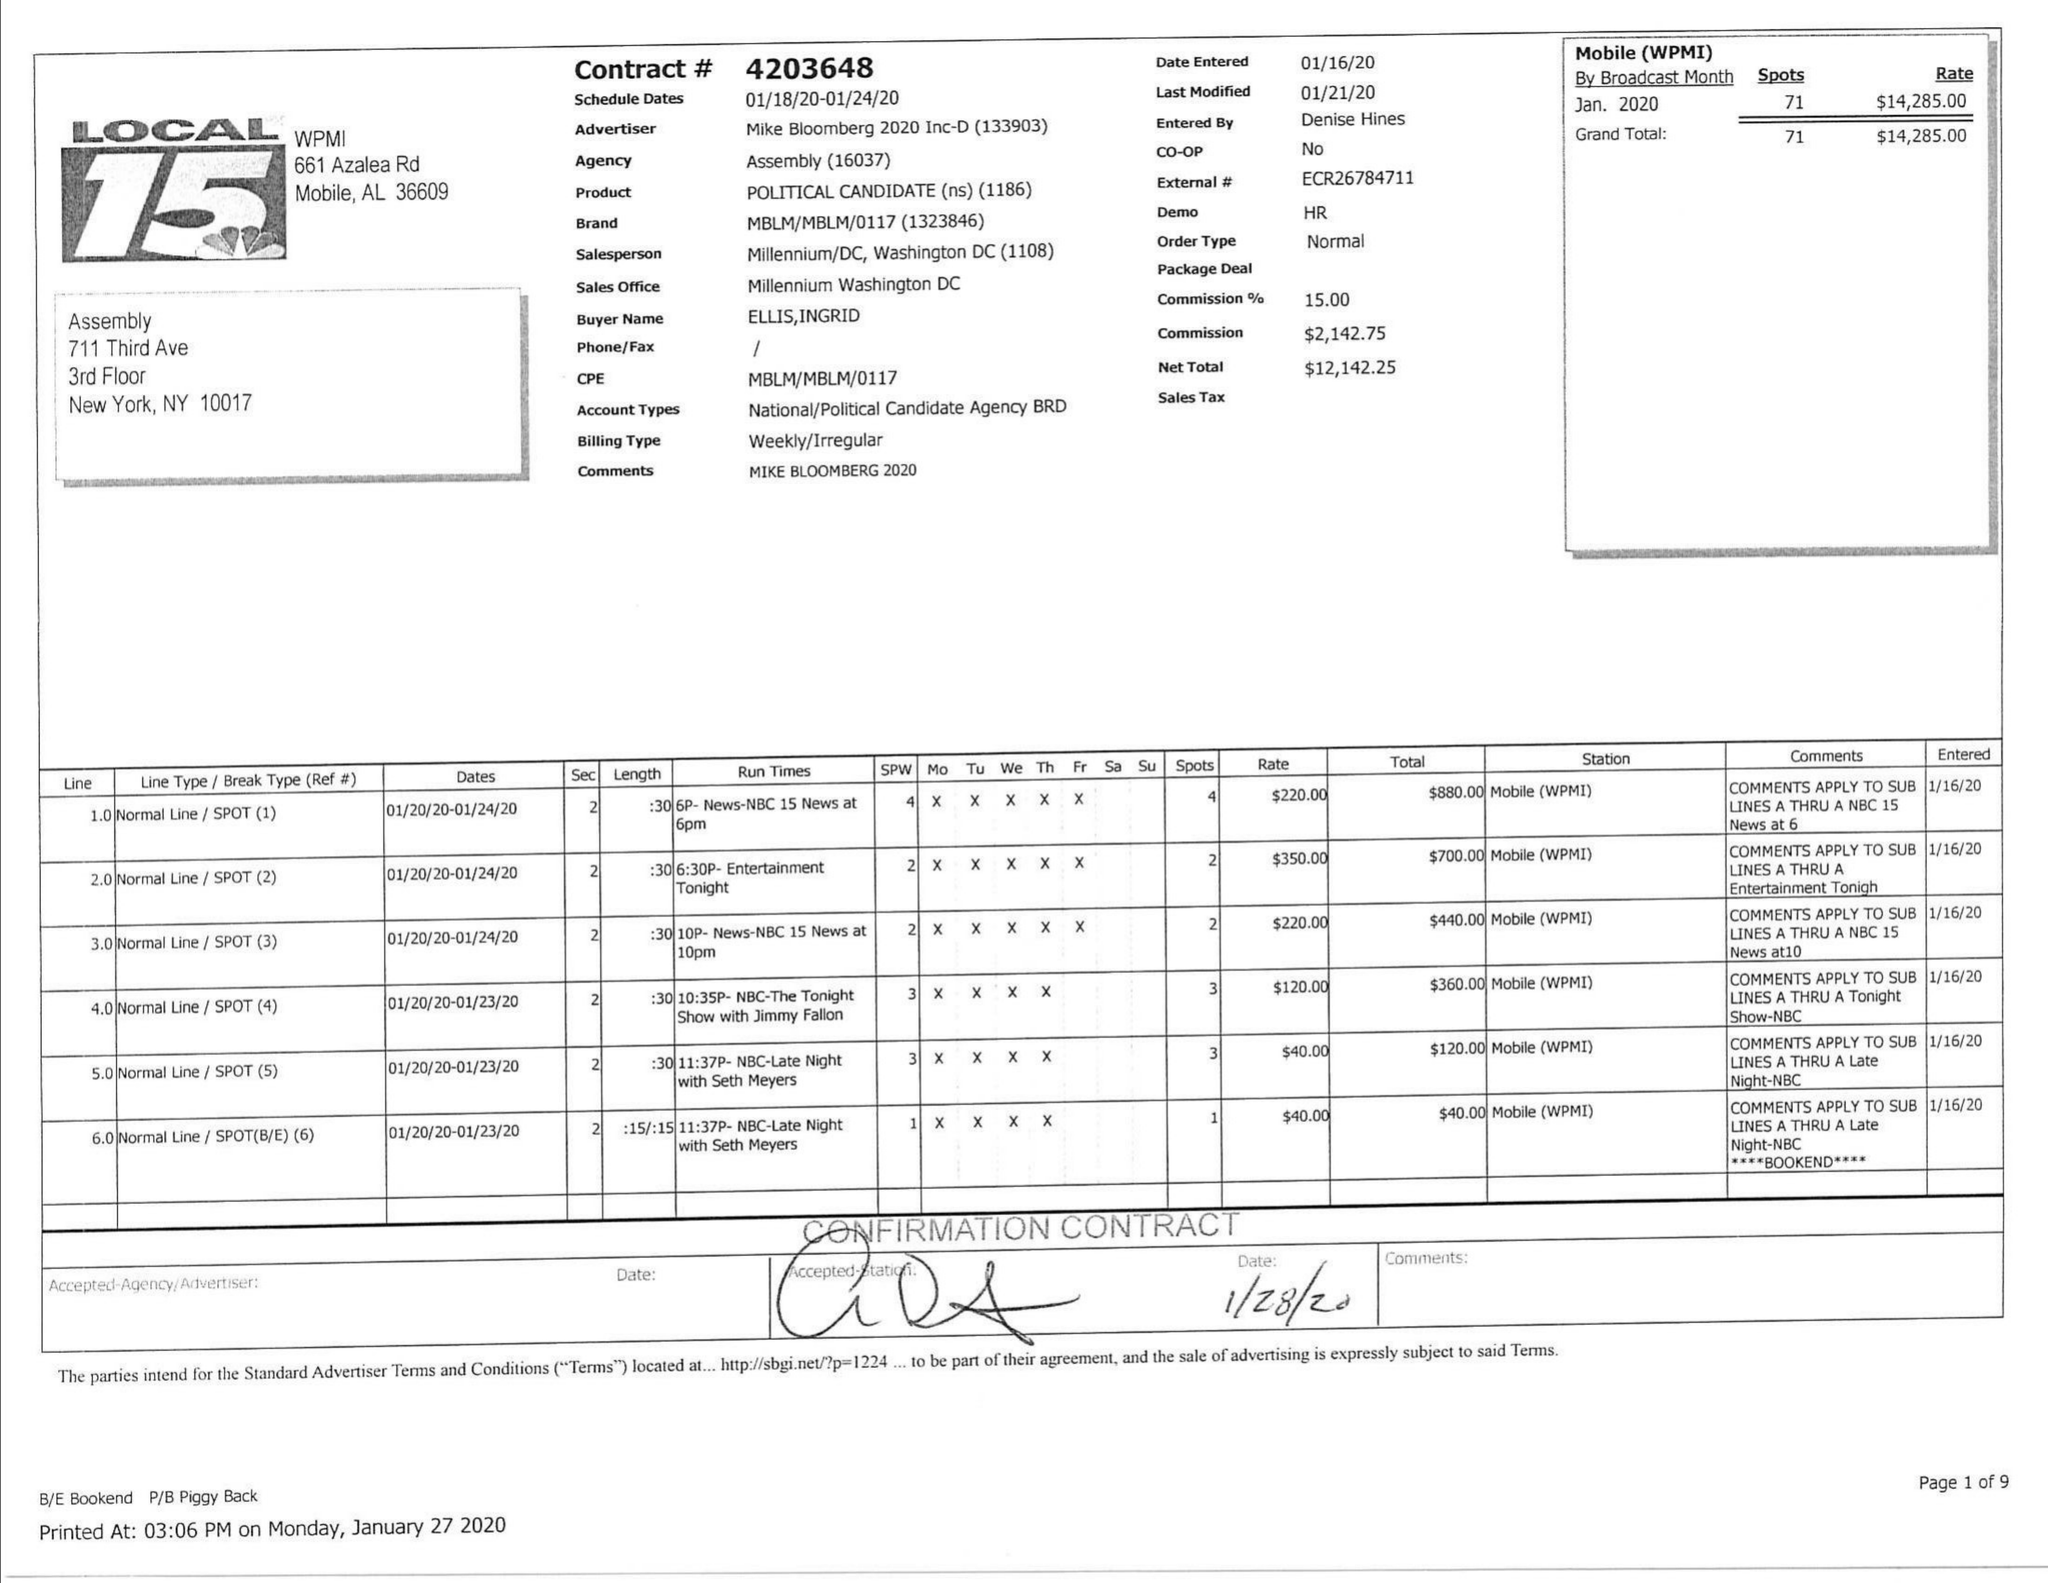What is the value for the gross_amount?
Answer the question using a single word or phrase. 314285.00 